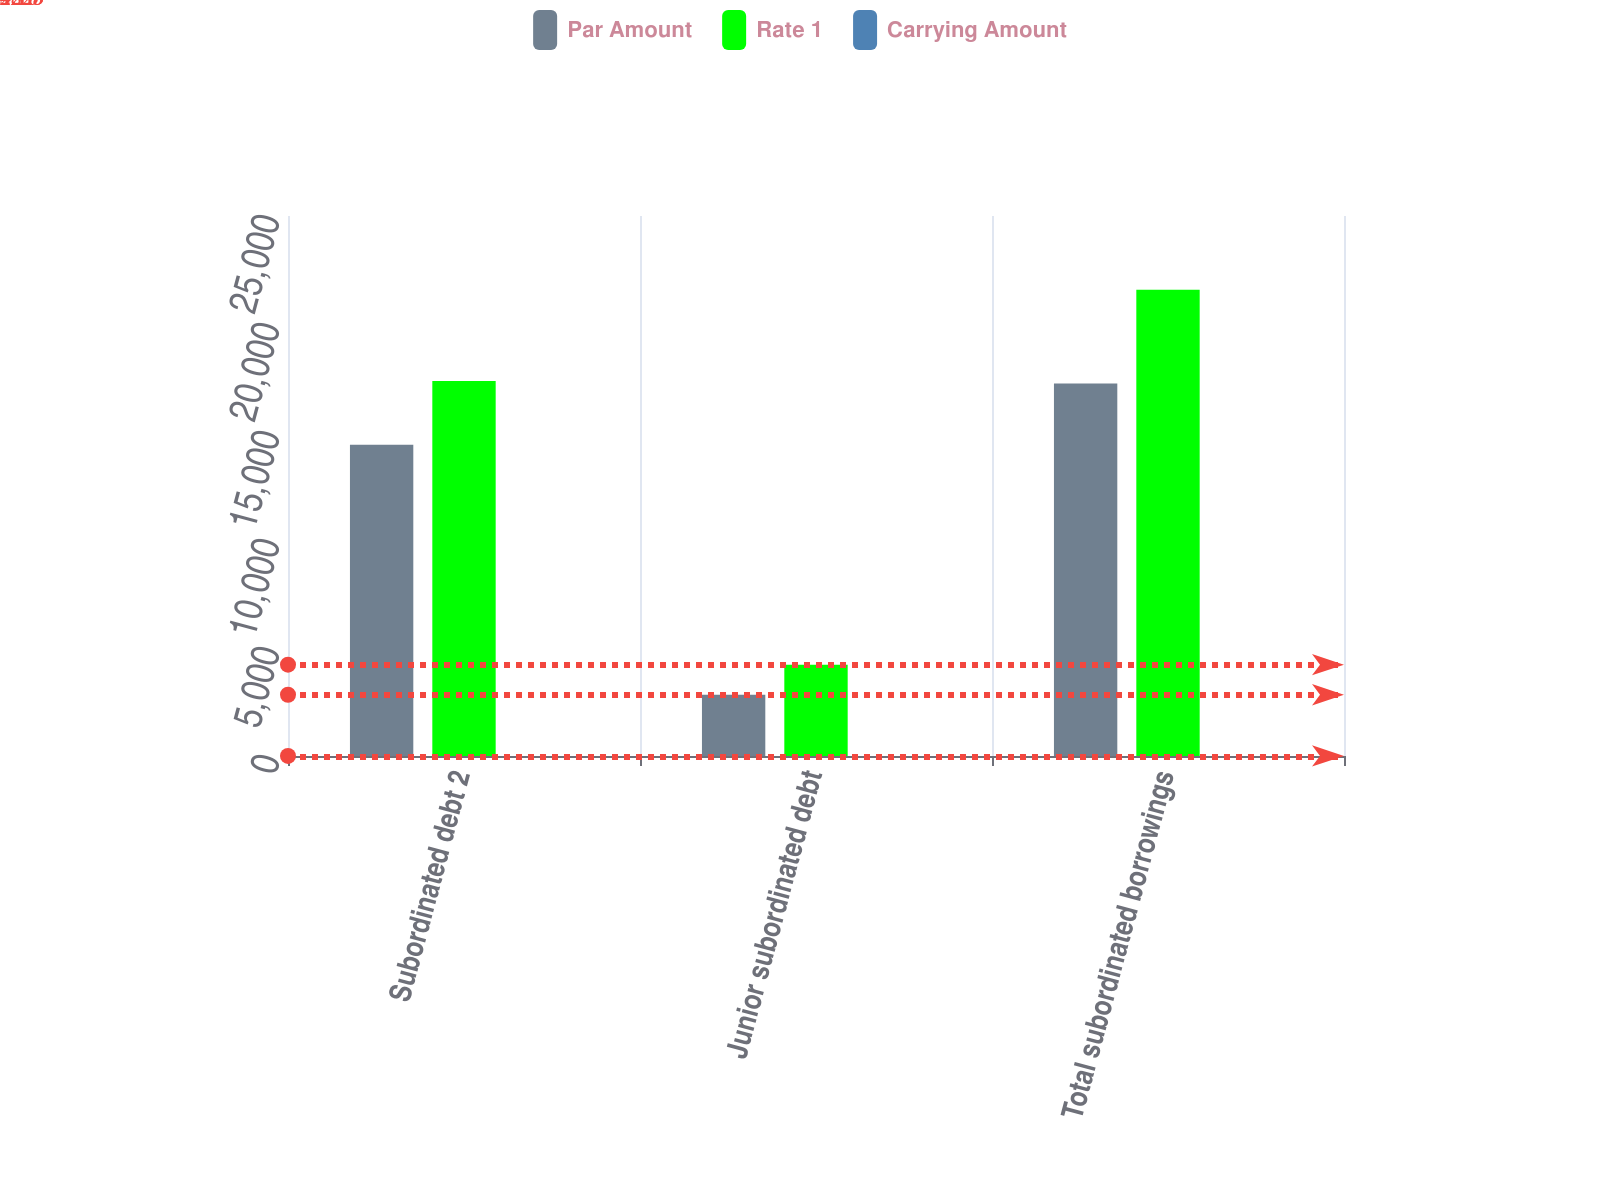Convert chart. <chart><loc_0><loc_0><loc_500><loc_500><stacked_bar_chart><ecel><fcel>Subordinated debt 2<fcel>Junior subordinated debt<fcel>Total subordinated borrowings<nl><fcel>Par Amount<fcel>14409<fcel>2835<fcel>17244<nl><fcel>Rate 1<fcel>17358<fcel>4228<fcel>21586<nl><fcel>Carrying Amount<fcel>4.24<fcel>3.16<fcel>4.06<nl></chart> 